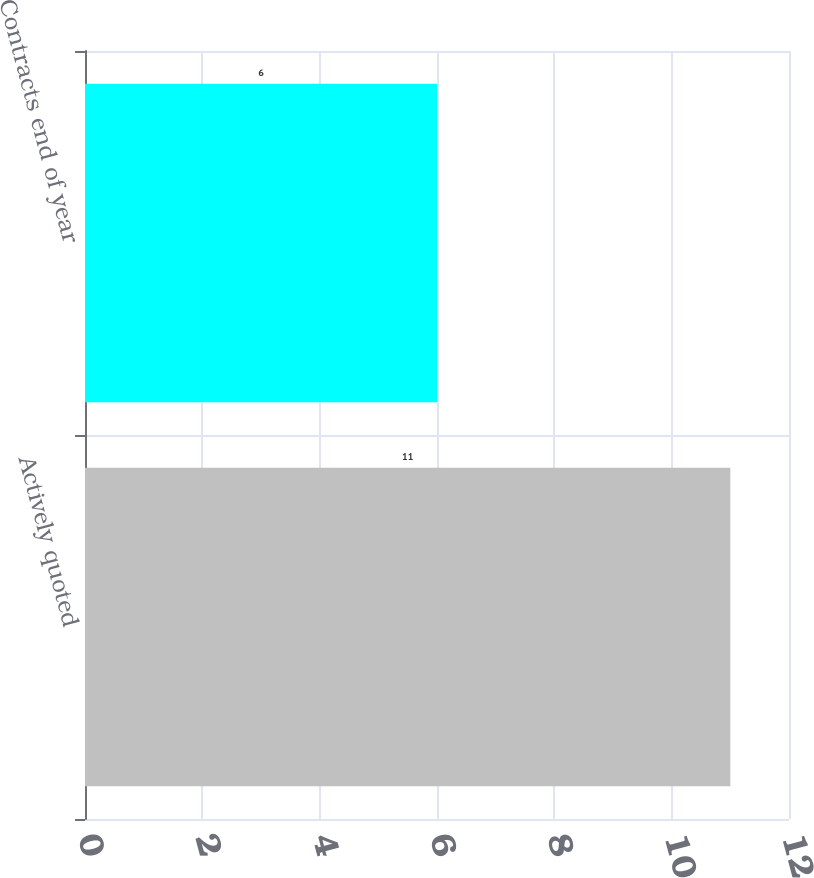<chart> <loc_0><loc_0><loc_500><loc_500><bar_chart><fcel>Actively quoted<fcel>Contracts end of year<nl><fcel>11<fcel>6<nl></chart> 